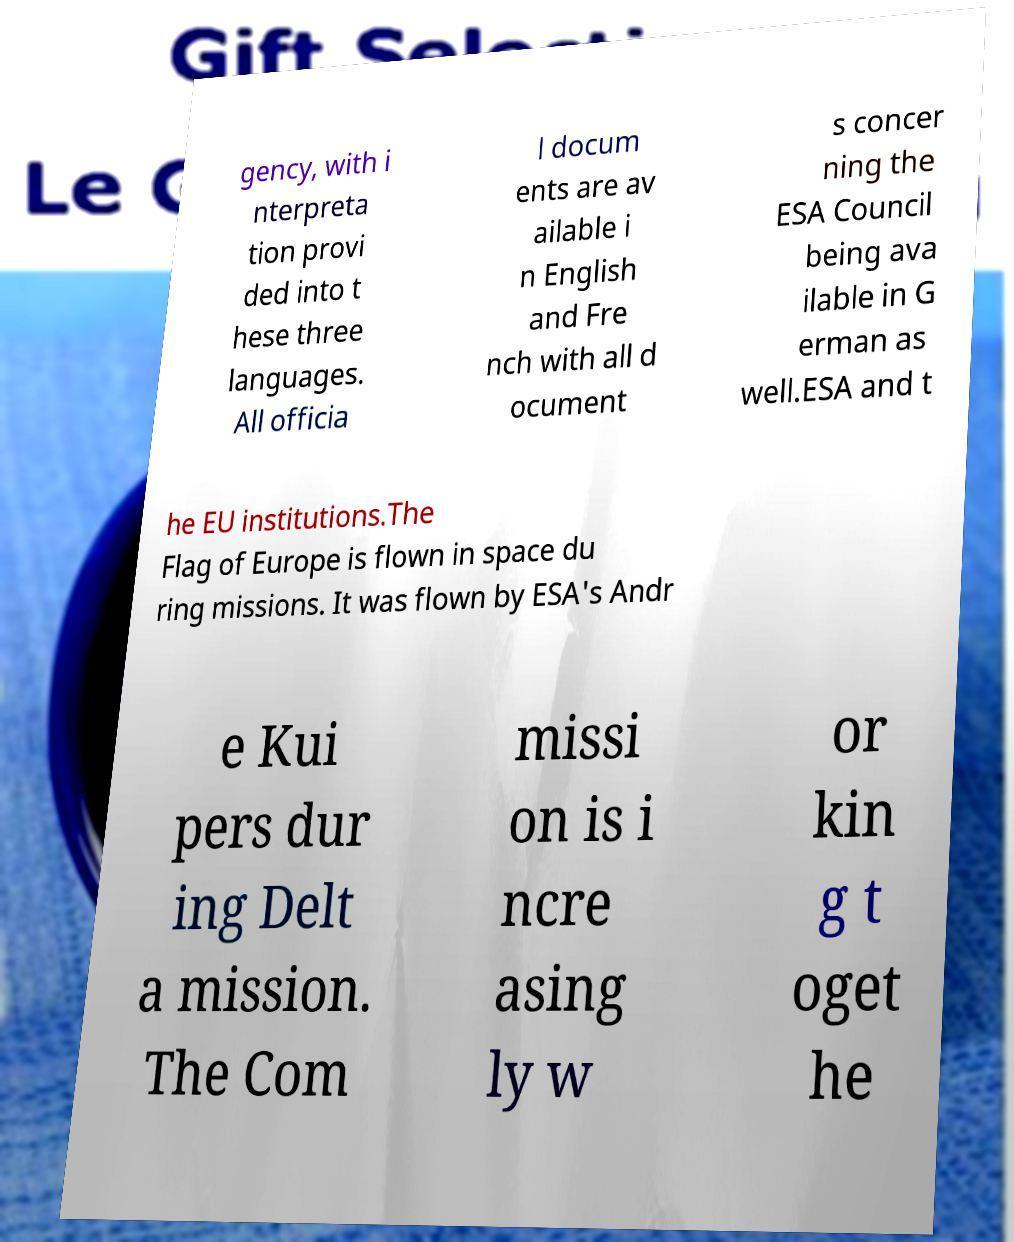Could you assist in decoding the text presented in this image and type it out clearly? gency, with i nterpreta tion provi ded into t hese three languages. All officia l docum ents are av ailable i n English and Fre nch with all d ocument s concer ning the ESA Council being ava ilable in G erman as well.ESA and t he EU institutions.The Flag of Europe is flown in space du ring missions. It was flown by ESA's Andr e Kui pers dur ing Delt a mission. The Com missi on is i ncre asing ly w or kin g t oget he 